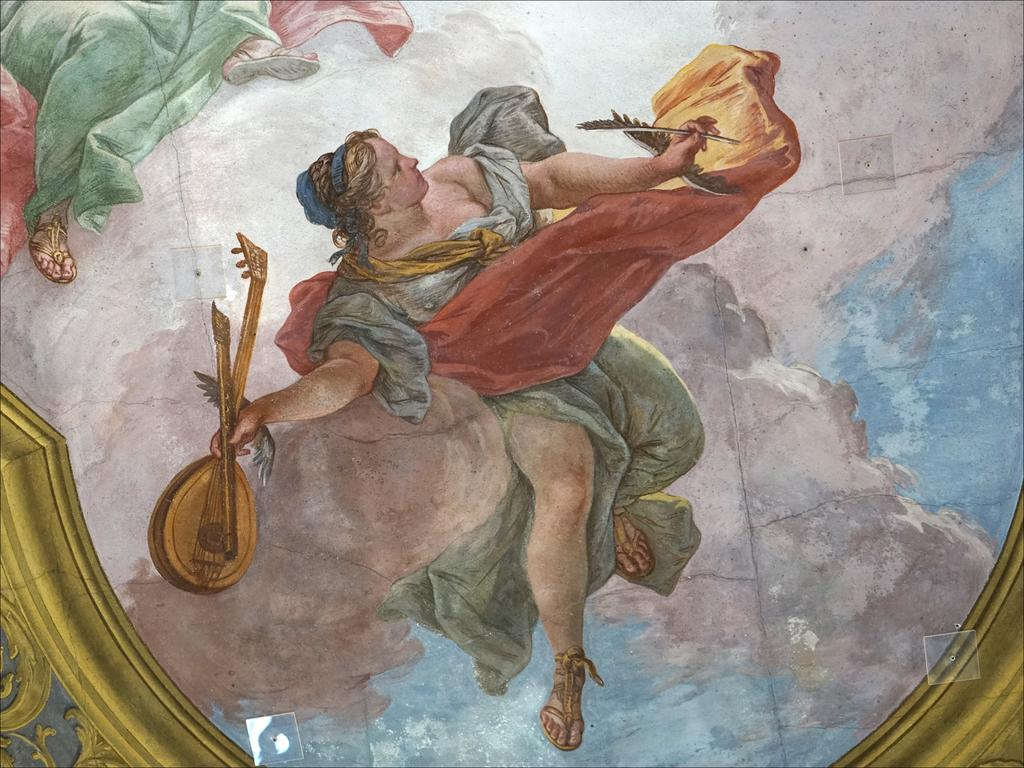What type of artwork is depicted in the image? The image is a painting. What is the person in the painting doing? The person is holding a musical instrument in the painting. Can you describe the other person in the painting? There is another person at the top of the painting. What type of silver control is visible in the painting? There is no silver control present in the painting. Is there a battle taking place in the painting? There is no battle depicted in the painting; it features a person holding a musical instrument and another person at the top of the painting. 